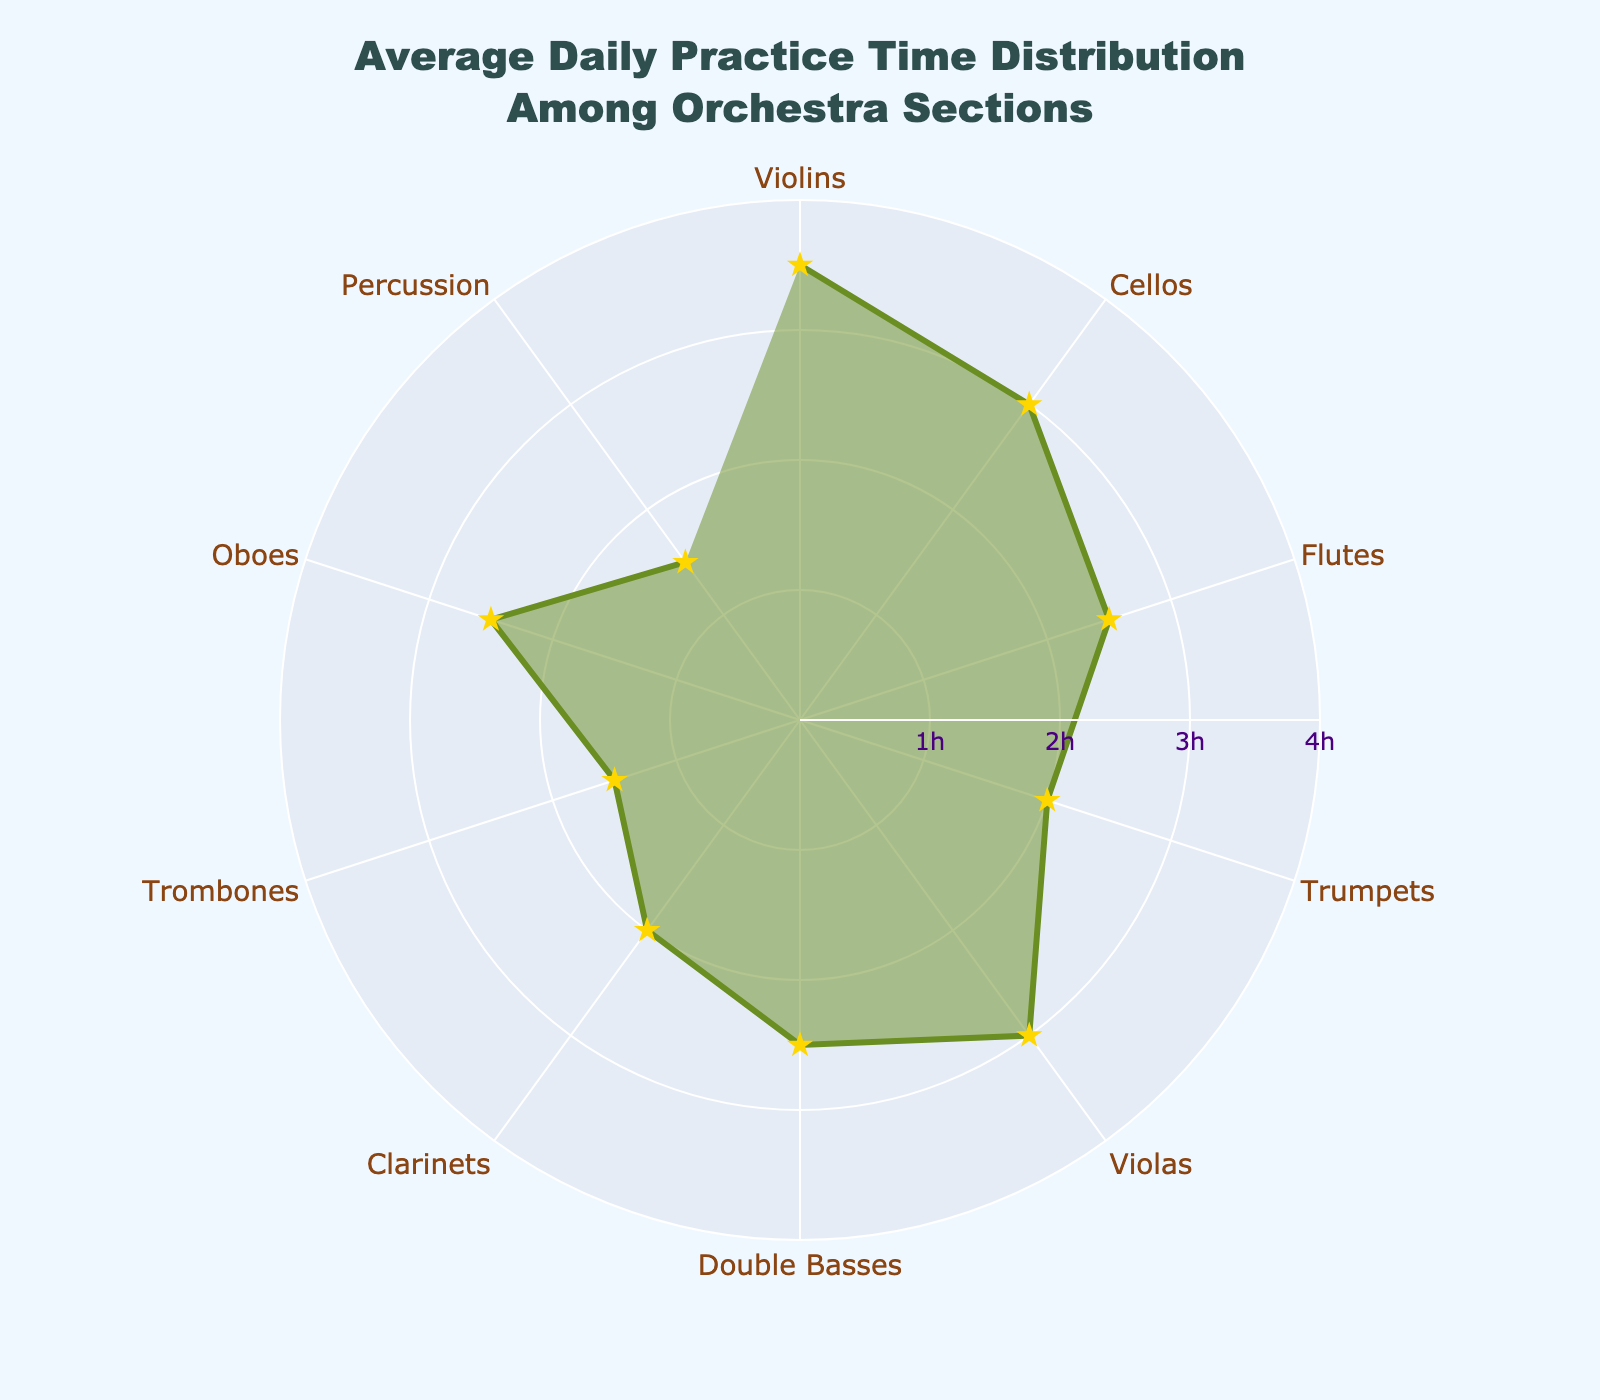What section has the highest average daily practice time? Looking at the plot, the section with the point farthest from the center represents the highest practice time. The Violins section is the farthest with 3.5 hours.
Answer: Violins Which sections have the same average daily practice time? Observing the plot, sections with points at the same distance from the center share the same practice time. Cellos and Violas both practice 3.0 hours, Flutes, Double Basses, and Oboes practice 2.5 hours, Clarinets and Trumpets practice 2.0 hours, and lastly, Trombones and Percussion practice 1.5 hours.
Answer: Cellos and Violas, Flutes, Double Basses, and Oboes, Clarinets and Trumpets, Trombones and Percussion What is the practice time range displayed on the plot? The outermost tick at the radial axis denotes the maximum practice time, and the innermost denotes the minimum. Maximum is 4 hours, while the minimum shown is 1 hour. Therefore, the range is 1 to 4 hours.
Answer: 1 to 4 hours How does the practice time of Flutes compare to Trumpets? According to the distances from the center, the practice time for Flutes is greater than that of Trumpets. Flutes are at 2.5 hours, while Trumpets are at 2.0 hours.
Answer: Flutes practice more than Trumpets Which section practices the least? The nearest points to the center indicate the least practice time. Both Trombones and Percussion share the closest points to the center at 1.5 hours.
Answer: Trombones and Percussion What is the total average daily practice time for Violins and Cellos? Add the average practice times of Violins and Cellos. Violins practice 3.5 hours, and Cellos practice 3.0 hours. So, 3.5 + 3.0 = 6.5 hours.
Answer: 6.5 hours How many sections practice exactly 2.5 hours a day? Count the sections where the radar points align with the 2.5-hour mark. These sections are Flutes, Double Basses, and Oboes, making a total of three sections.
Answer: 3 sections What is the difference in practice time between Violins and Trombones? Subtract the practice time of Trombones from Violins. Violins practice 3.5 hours, while Trombones practice 1.5 hours. So, 3.5 - 1.5 = 2 hours.
Answer: 2 hours Which section practices more: Double Basses or Clarinets? Comparing the distances from the center, Double Basses (2.5 hours) practice more than Clarinets (2.0 hours).
Answer: Double Basses What's the average practice time of sections that practice more than 2 hours a day? Identify sections practicing more than 2 hours: Violins (3.5), Cellos (3.0), Flutes (2.5), Violas (3.0), Double Basses (2.5), and Oboes (2.5). Add these times: 3.5 + 3 + 2.5 + 3 + 2.5 + 2.5 = 17. Divide by the number of sections, 17/6 = 2.83.
Answer: 2.83 hours 